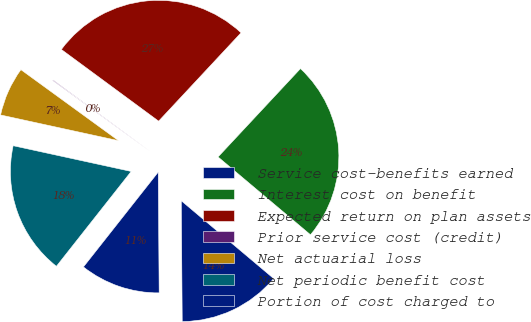<chart> <loc_0><loc_0><loc_500><loc_500><pie_chart><fcel>Service cost-benefits earned<fcel>Interest cost on benefit<fcel>Expected return on plan assets<fcel>Prior service cost (credit)<fcel>Net actuarial loss<fcel>Net periodic benefit cost<fcel>Portion of cost charged to<nl><fcel>13.74%<fcel>24.19%<fcel>26.84%<fcel>0.1%<fcel>6.59%<fcel>17.79%<fcel>10.75%<nl></chart> 